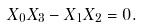<formula> <loc_0><loc_0><loc_500><loc_500>X _ { 0 } X _ { 3 } - X _ { 1 } X _ { 2 } = 0 .</formula> 